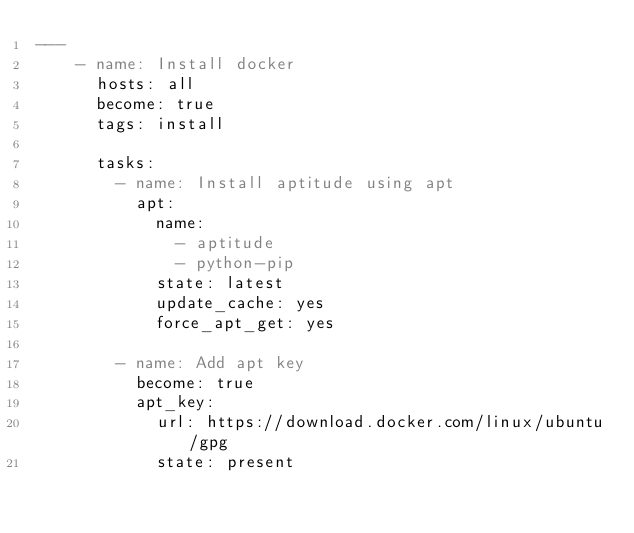<code> <loc_0><loc_0><loc_500><loc_500><_YAML_>---
    - name: Install docker
      hosts: all
      become: true
      tags: install

      tasks:
        - name: Install aptitude using apt
          apt:
            name:
              - aptitude
              - python-pip
            state: latest
            update_cache: yes
            force_apt_get: yes

        - name: Add apt key
          become: true
          apt_key:
            url: https://download.docker.com/linux/ubuntu/gpg
            state: present
</code> 